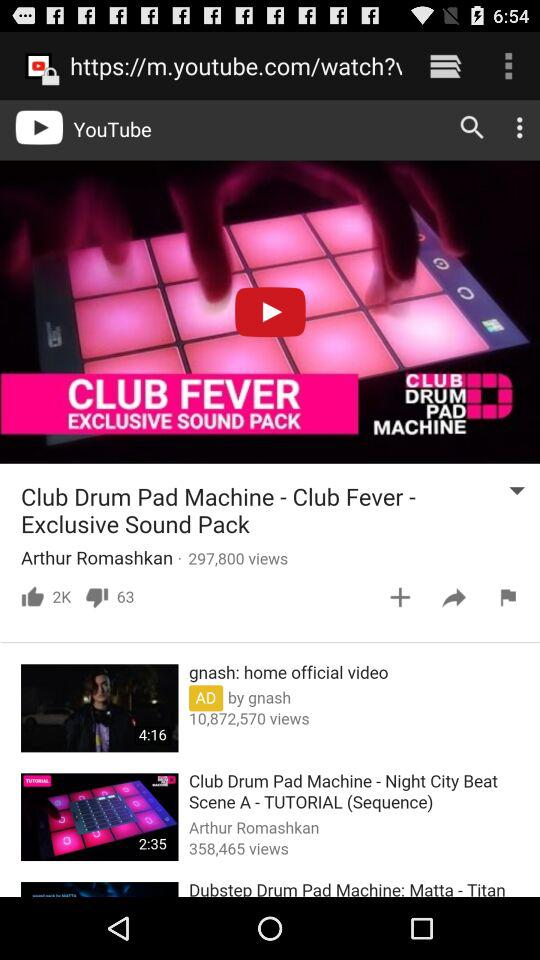What is the number of views of "gnash: home official video"? The number of views is 10,872,570. 